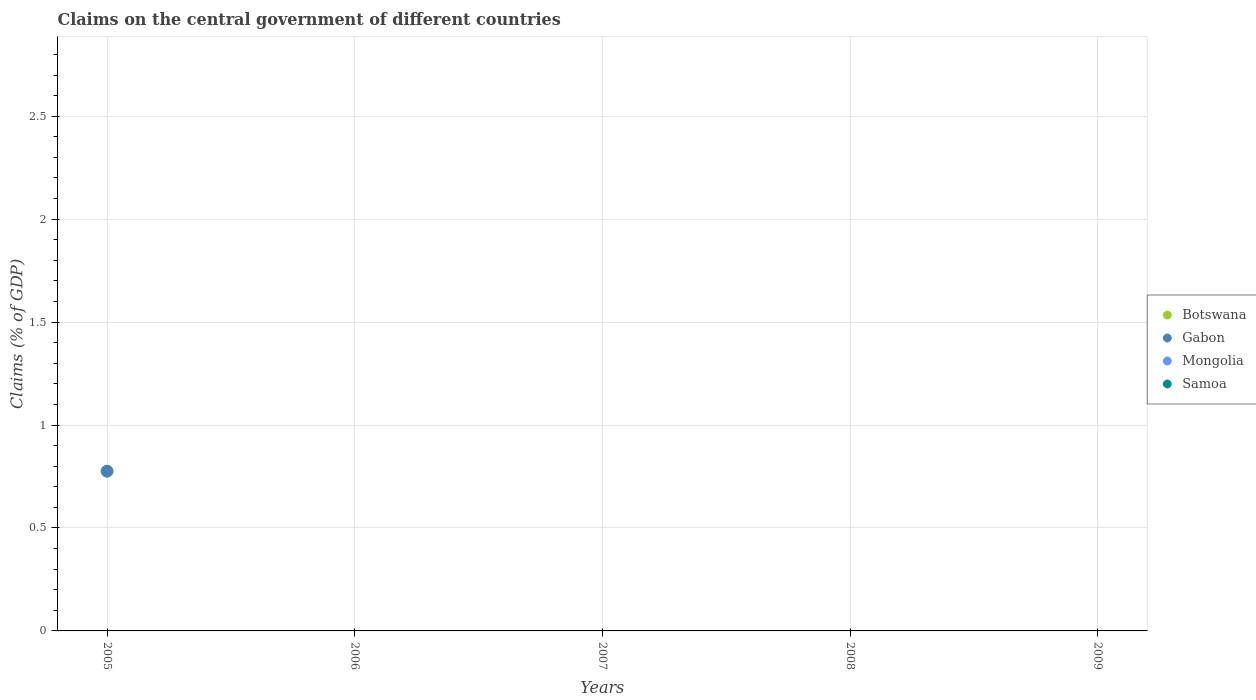What is the total percentage of GDP claimed on the central government in Gabon in the graph?
Keep it short and to the point. 0.78. What is the average percentage of GDP claimed on the central government in Botswana per year?
Offer a terse response. 0. In how many years, is the percentage of GDP claimed on the central government in Samoa greater than 2.4 %?
Ensure brevity in your answer.  0. What is the difference between the highest and the lowest percentage of GDP claimed on the central government in Gabon?
Your answer should be compact. 0.78. In how many years, is the percentage of GDP claimed on the central government in Samoa greater than the average percentage of GDP claimed on the central government in Samoa taken over all years?
Your response must be concise. 0. Is it the case that in every year, the sum of the percentage of GDP claimed on the central government in Gabon and percentage of GDP claimed on the central government in Mongolia  is greater than the sum of percentage of GDP claimed on the central government in Botswana and percentage of GDP claimed on the central government in Samoa?
Make the answer very short. No. Is it the case that in every year, the sum of the percentage of GDP claimed on the central government in Botswana and percentage of GDP claimed on the central government in Samoa  is greater than the percentage of GDP claimed on the central government in Mongolia?
Provide a short and direct response. No. How many dotlines are there?
Your answer should be very brief. 1. How many years are there in the graph?
Give a very brief answer. 5. What is the difference between two consecutive major ticks on the Y-axis?
Offer a terse response. 0.5. Does the graph contain any zero values?
Keep it short and to the point. Yes. How are the legend labels stacked?
Keep it short and to the point. Vertical. What is the title of the graph?
Ensure brevity in your answer.  Claims on the central government of different countries. What is the label or title of the Y-axis?
Offer a very short reply. Claims (% of GDP). What is the Claims (% of GDP) of Botswana in 2005?
Offer a terse response. 0. What is the Claims (% of GDP) in Gabon in 2005?
Provide a short and direct response. 0.78. What is the Claims (% of GDP) in Mongolia in 2005?
Your answer should be very brief. 0. What is the Claims (% of GDP) in Botswana in 2006?
Your answer should be compact. 0. What is the Claims (% of GDP) of Samoa in 2006?
Ensure brevity in your answer.  0. What is the Claims (% of GDP) of Botswana in 2008?
Your response must be concise. 0. What is the Claims (% of GDP) of Gabon in 2008?
Make the answer very short. 0. What is the Claims (% of GDP) of Botswana in 2009?
Ensure brevity in your answer.  0. Across all years, what is the maximum Claims (% of GDP) of Gabon?
Give a very brief answer. 0.78. What is the total Claims (% of GDP) in Gabon in the graph?
Your response must be concise. 0.78. What is the average Claims (% of GDP) of Gabon per year?
Provide a short and direct response. 0.16. What is the average Claims (% of GDP) in Samoa per year?
Your answer should be very brief. 0. What is the difference between the highest and the lowest Claims (% of GDP) in Gabon?
Give a very brief answer. 0.78. 